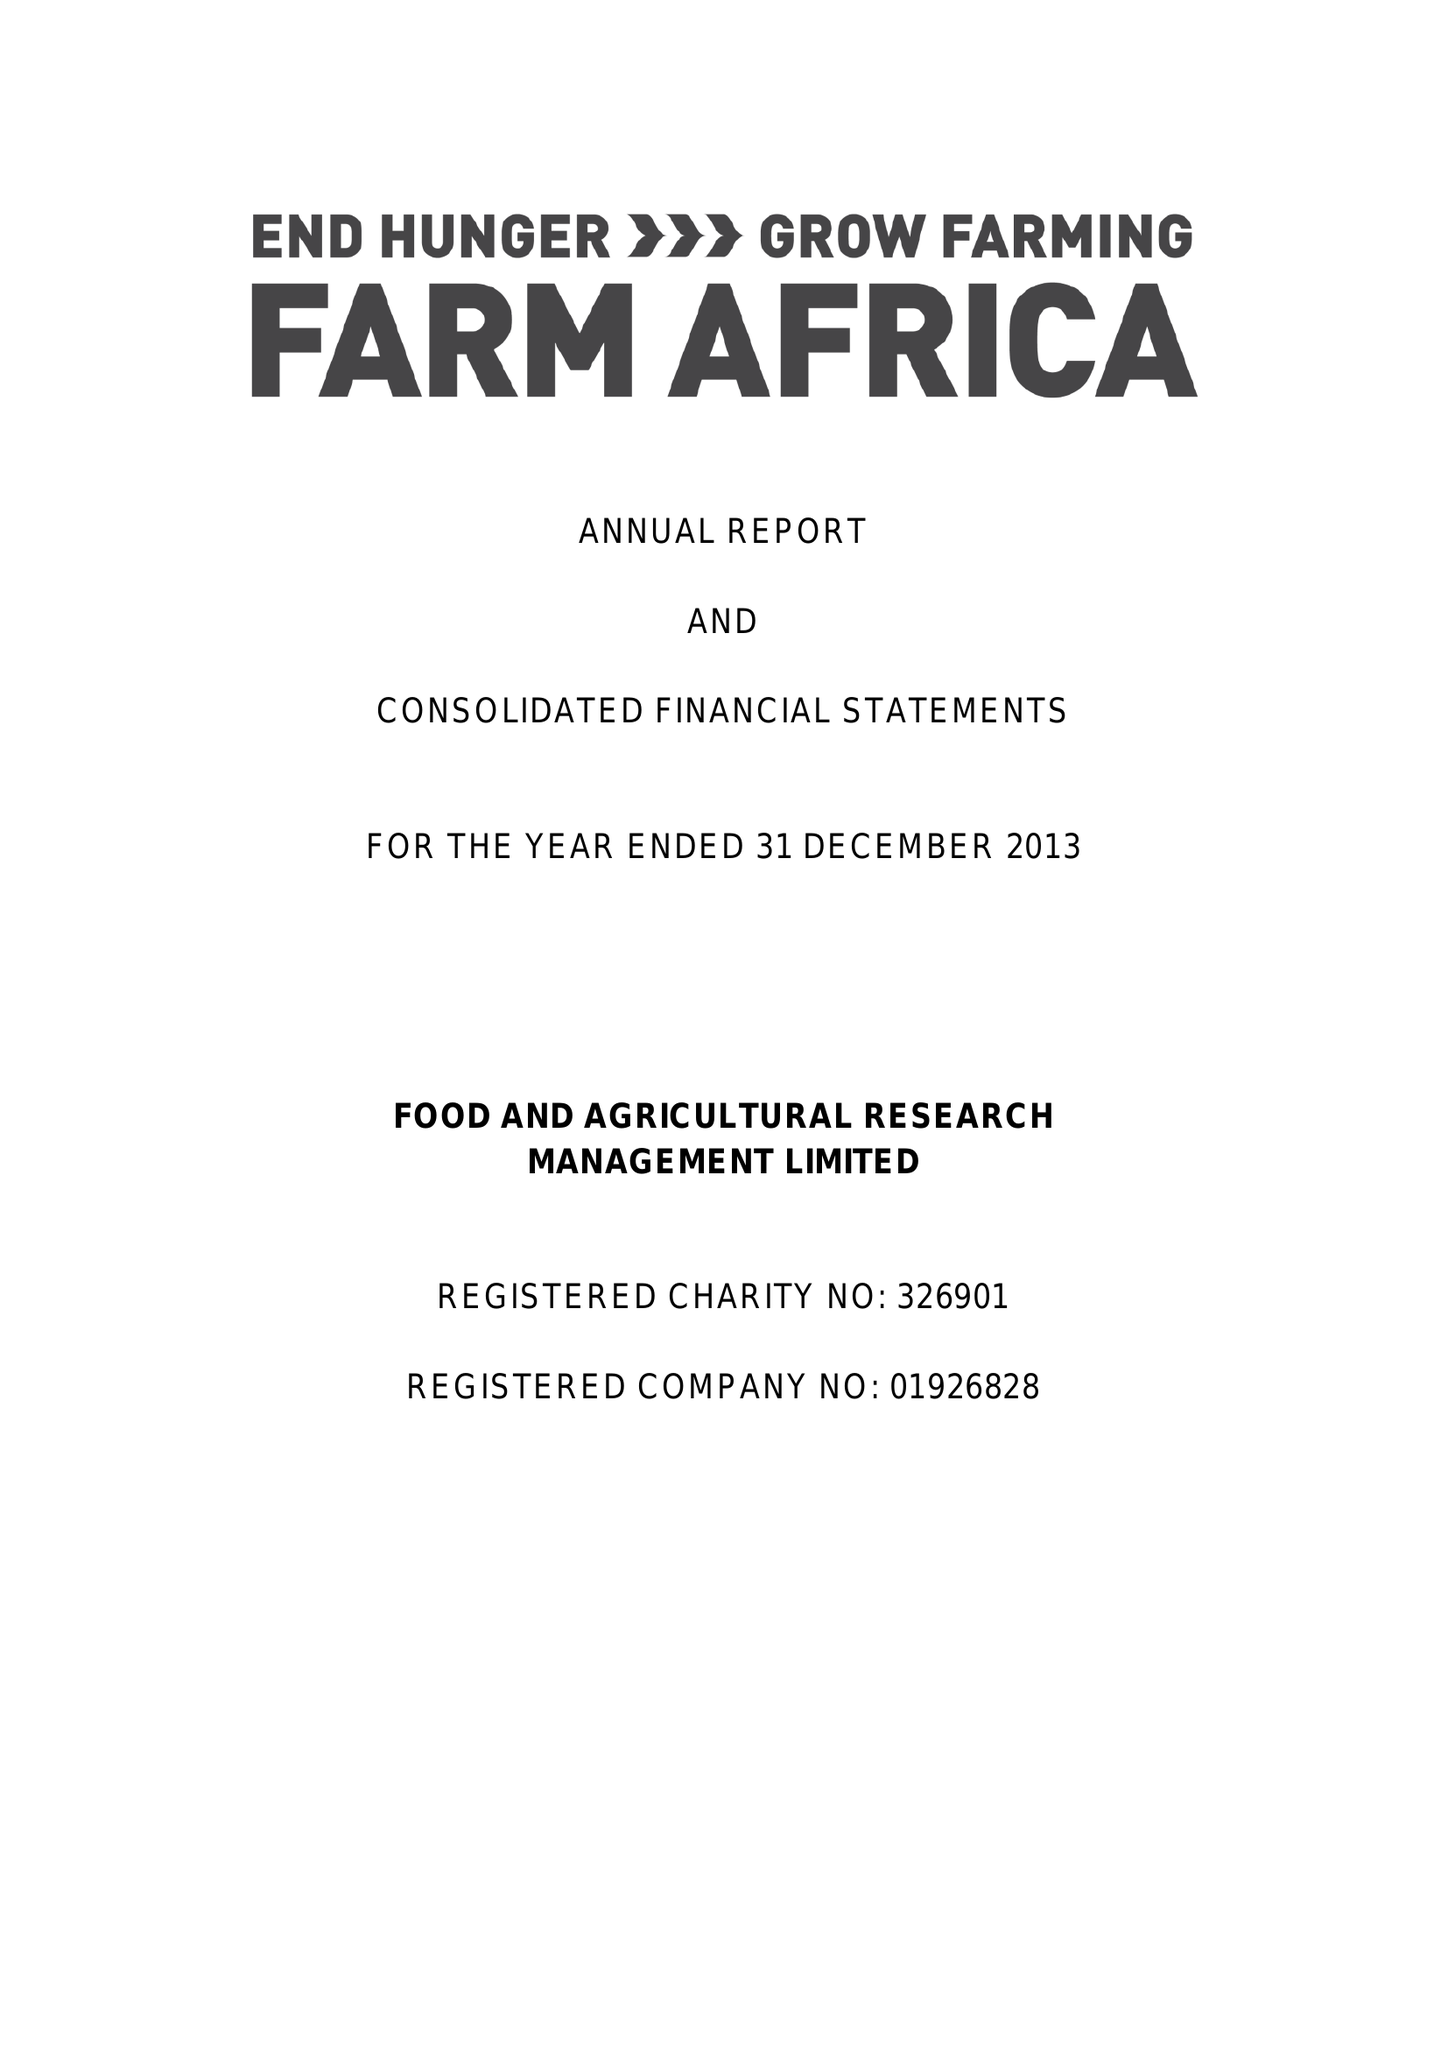What is the value for the spending_annually_in_british_pounds?
Answer the question using a single word or phrase. 12510000.00 